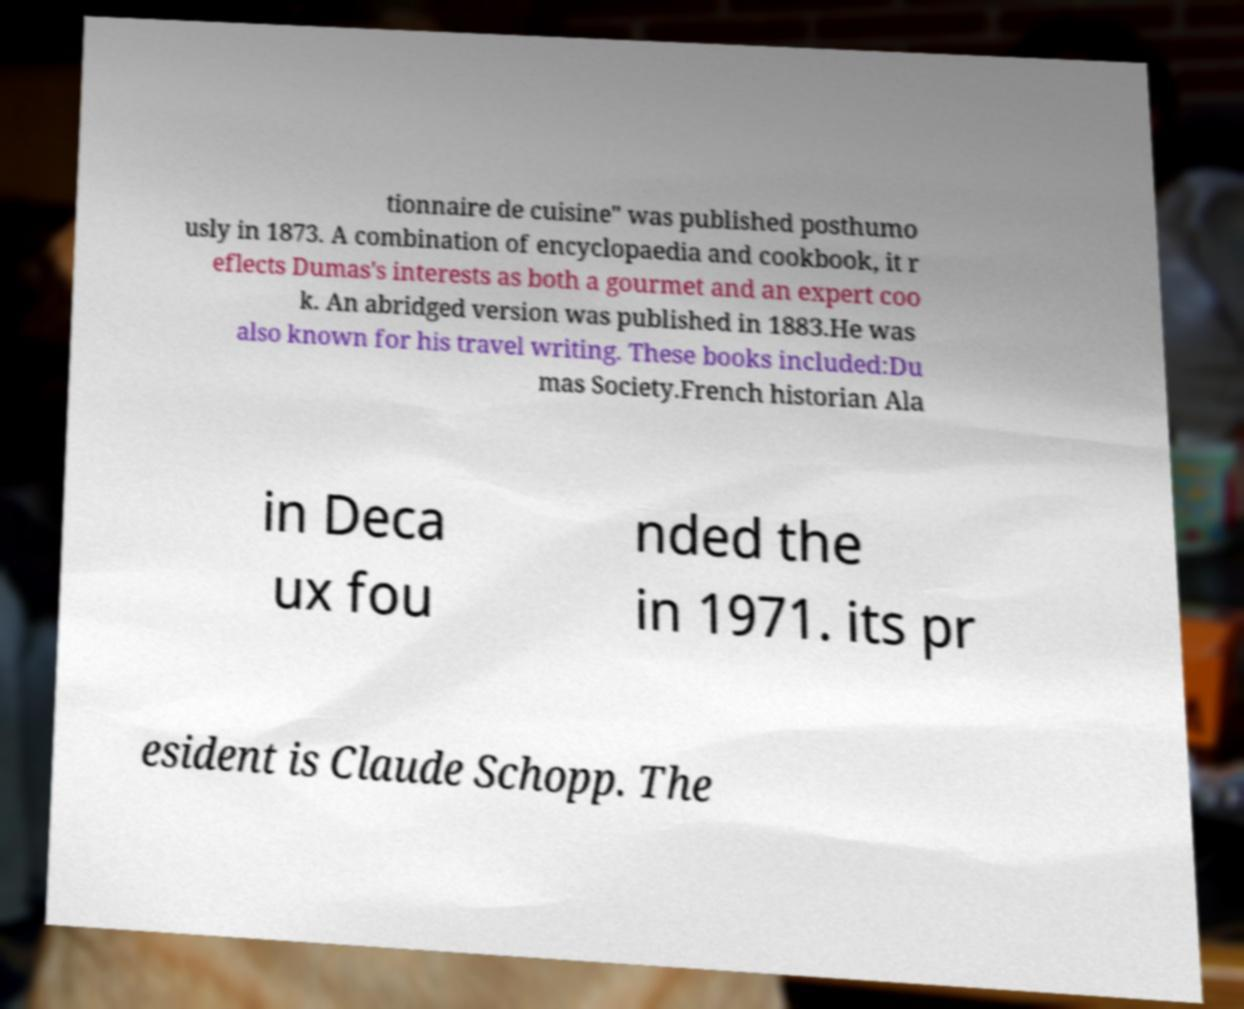Could you extract and type out the text from this image? tionnaire de cuisine" was published posthumo usly in 1873. A combination of encyclopaedia and cookbook, it r eflects Dumas's interests as both a gourmet and an expert coo k. An abridged version was published in 1883.He was also known for his travel writing. These books included:Du mas Society.French historian Ala in Deca ux fou nded the in 1971. its pr esident is Claude Schopp. The 